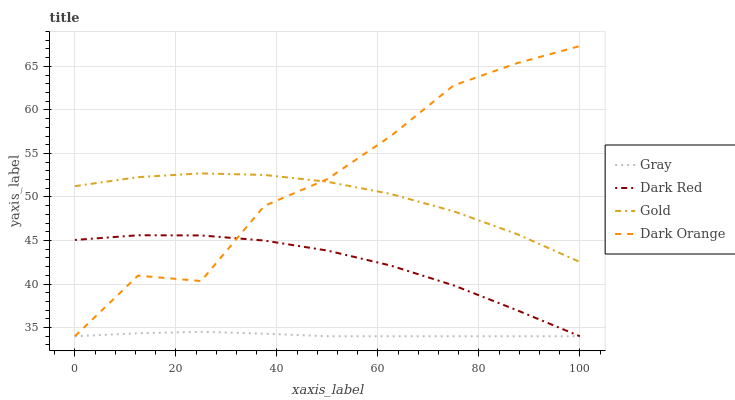Does Gold have the minimum area under the curve?
Answer yes or no. No. Does Gold have the maximum area under the curve?
Answer yes or no. No. Is Gold the smoothest?
Answer yes or no. No. Is Gold the roughest?
Answer yes or no. No. Does Gold have the lowest value?
Answer yes or no. No. Does Gold have the highest value?
Answer yes or no. No. Is Gray less than Gold?
Answer yes or no. Yes. Is Gold greater than Dark Red?
Answer yes or no. Yes. Does Gray intersect Gold?
Answer yes or no. No. 